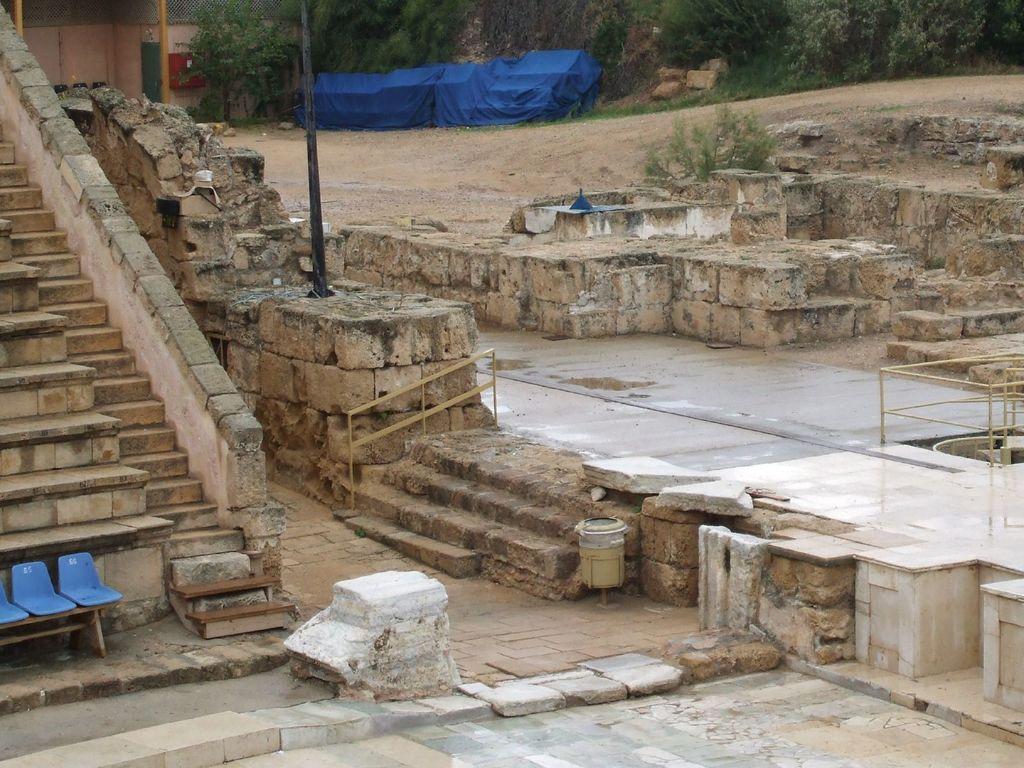Could you give a brief overview of what you see in this image? In the image in the center we can see wall,staircase,attached chairs,fence,blue color object,plants and poles. In the background we can see trees,blue color curtain,stones,grass,wall etc. 